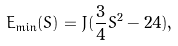<formula> <loc_0><loc_0><loc_500><loc_500>E _ { \min } ( S ) = J ( \frac { 3 } { 4 } S ^ { 2 } - 2 4 ) ,</formula> 